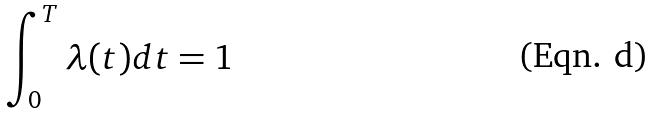Convert formula to latex. <formula><loc_0><loc_0><loc_500><loc_500>\int _ { 0 } ^ { T } \lambda ( t ) d t = 1</formula> 